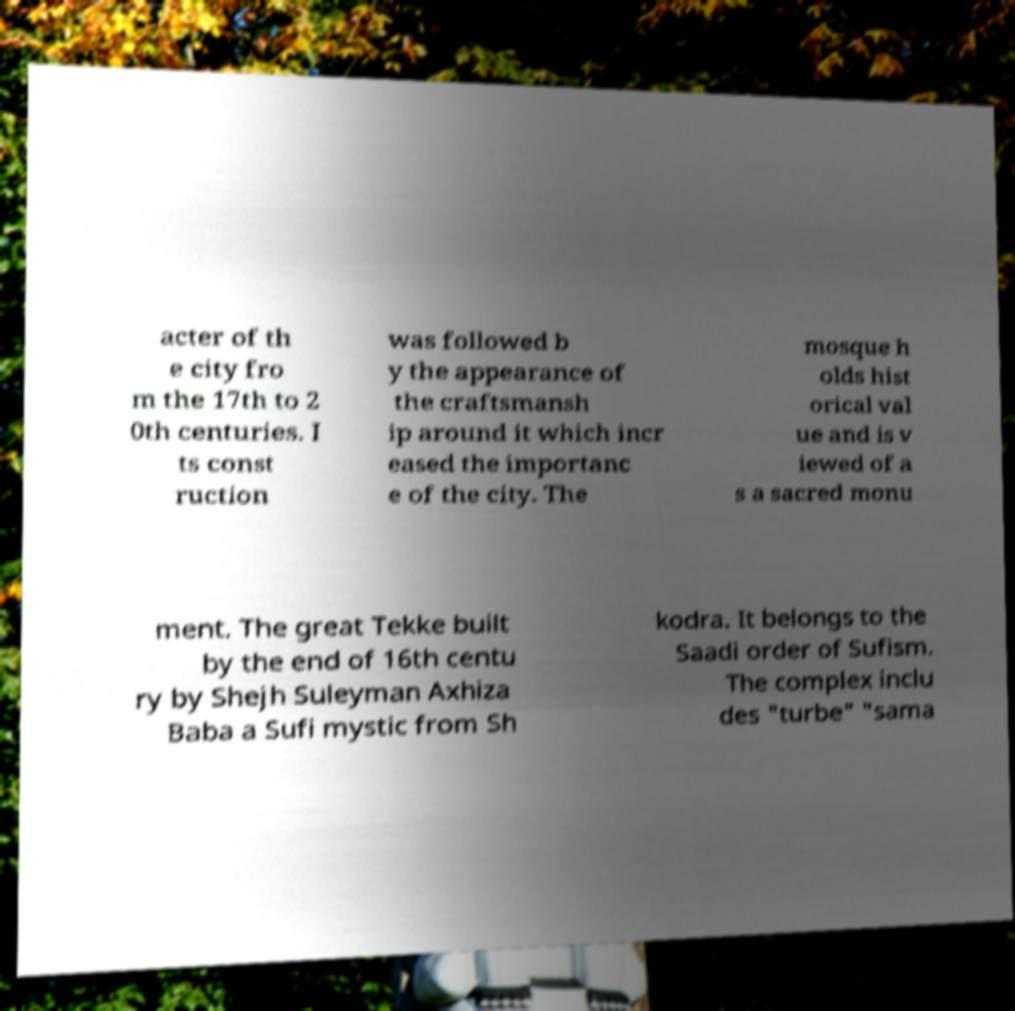Please read and relay the text visible in this image. What does it say? acter of th e city fro m the 17th to 2 0th centuries. I ts const ruction was followed b y the appearance of the craftsmansh ip around it which incr eased the importanc e of the city. The mosque h olds hist orical val ue and is v iewed of a s a sacred monu ment. The great Tekke built by the end of 16th centu ry by Shejh Suleyman Axhiza Baba a Sufi mystic from Sh kodra. It belongs to the Saadi order of Sufism. The complex inclu des "turbe" "sama 